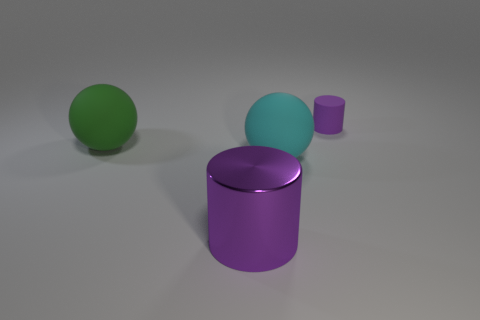There is a cylinder that is the same color as the large shiny thing; what is it made of?
Keep it short and to the point. Rubber. How many matte things are either purple cylinders or small purple cubes?
Offer a terse response. 1. There is a matte sphere that is right of the thing that is in front of the big cyan rubber thing; are there any purple cylinders behind it?
Offer a very short reply. Yes. What color is the large cylinder?
Ensure brevity in your answer.  Purple. There is a cyan object to the right of the green matte object; does it have the same shape as the purple metal thing?
Your answer should be compact. No. How many things are either big yellow blocks or big objects behind the large purple metallic cylinder?
Make the answer very short. 2. Do the purple thing to the left of the purple matte cylinder and the tiny purple cylinder have the same material?
Your answer should be very brief. No. Is there anything else that is the same size as the purple rubber object?
Provide a succinct answer. No. What material is the purple object on the right side of the purple object to the left of the tiny matte thing made of?
Your answer should be very brief. Rubber. Are there more spheres that are behind the cyan thing than big green spheres that are behind the big green rubber thing?
Make the answer very short. Yes. 